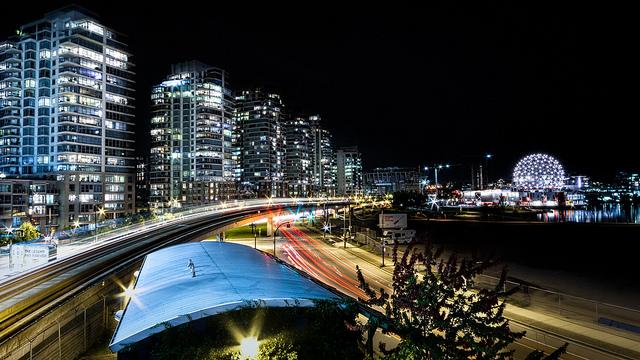Are there moving cars in this photo?
Write a very short answer. Yes. Is it night time?
Quick response, please. Yes. What color is this roof?
Quick response, please. Blue. 